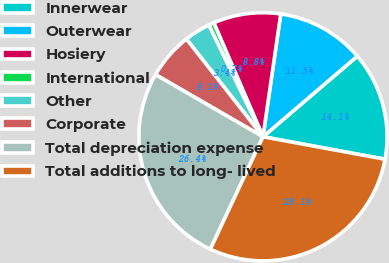Convert chart. <chart><loc_0><loc_0><loc_500><loc_500><pie_chart><fcel>Innerwear<fcel>Outerwear<fcel>Hosiery<fcel>International<fcel>Other<fcel>Corporate<fcel>Total depreciation expense<fcel>Total additions to long- lived<nl><fcel>14.15%<fcel>11.46%<fcel>8.77%<fcel>0.7%<fcel>3.39%<fcel>6.08%<fcel>26.38%<fcel>29.07%<nl></chart> 